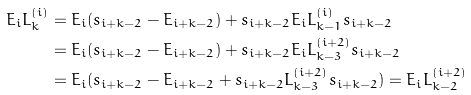Convert formula to latex. <formula><loc_0><loc_0><loc_500><loc_500>E _ { i } L ^ { ( i ) } _ { k } & = E _ { i } ( s _ { i + k - 2 } - E _ { i + k - 2 } ) + s _ { i + k - 2 } E _ { i } L ^ { ( i ) } _ { k - 1 } s _ { i + k - 2 } \\ & = E _ { i } ( s _ { i + k - 2 } - E _ { i + k - 2 } ) + s _ { i + k - 2 } E _ { i } L ^ { ( i + 2 ) } _ { k - 3 } s _ { i + k - 2 } \\ & = E _ { i } ( s _ { i + k - 2 } - E _ { i + k - 2 } + s _ { i + k - 2 } L ^ { ( i + 2 ) } _ { k - 3 } s _ { i + k - 2 } ) = E _ { i } L ^ { ( i + 2 ) } _ { k - 2 }</formula> 